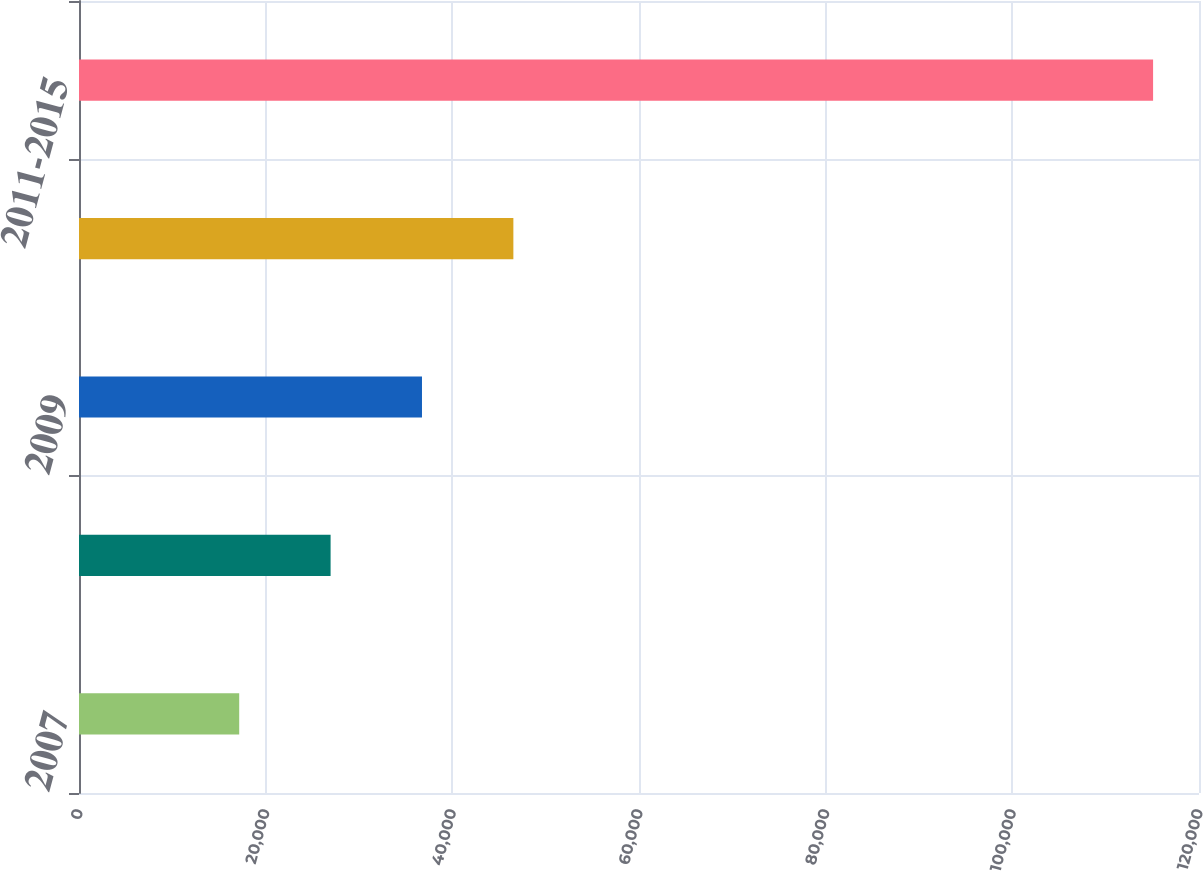Convert chart to OTSL. <chart><loc_0><loc_0><loc_500><loc_500><bar_chart><fcel>2007<fcel>2008<fcel>2009<fcel>2010<fcel>2011-2015<nl><fcel>17165<fcel>26956.5<fcel>36748<fcel>46539.5<fcel>115080<nl></chart> 